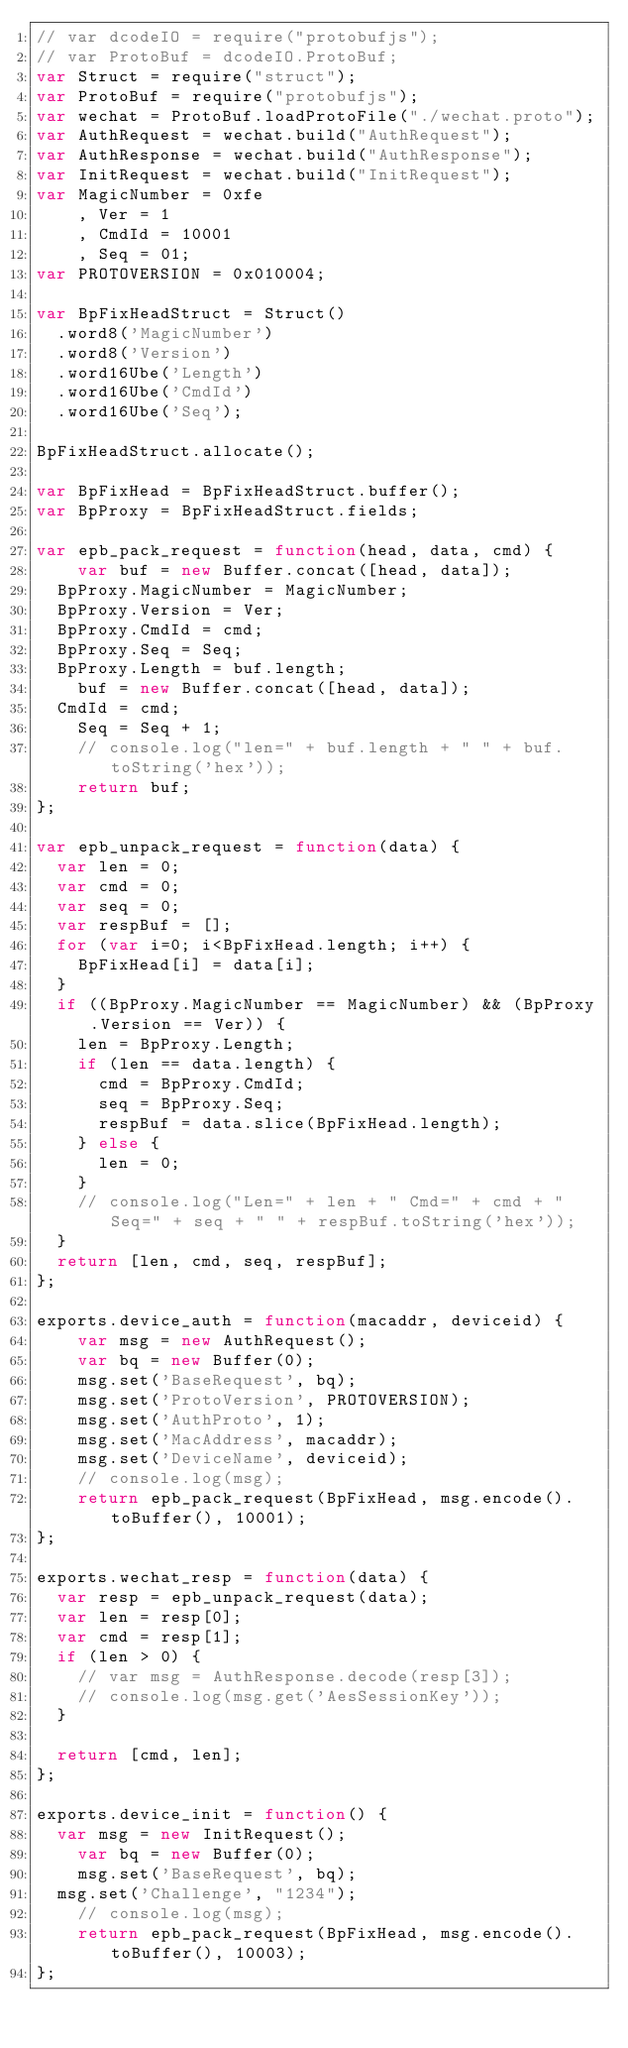<code> <loc_0><loc_0><loc_500><loc_500><_JavaScript_>// var dcodeIO = require("protobufjs");
// var ProtoBuf = dcodeIO.ProtoBuf;
var Struct = require("struct");
var ProtoBuf = require("protobufjs");
var wechat = ProtoBuf.loadProtoFile("./wechat.proto");
var AuthRequest = wechat.build("AuthRequest");
var AuthResponse = wechat.build("AuthResponse");
var InitRequest = wechat.build("InitRequest"); 
var MagicNumber = 0xfe
    , Ver = 1
    , CmdId = 10001
    , Seq = 01;
var PROTOVERSION = 0x010004;

var BpFixHeadStruct = Struct()
	.word8('MagicNumber')
	.word8('Version')
	.word16Ube('Length')
	.word16Ube('CmdId')
	.word16Ube('Seq');

BpFixHeadStruct.allocate();

var BpFixHead = BpFixHeadStruct.buffer();
var BpProxy = BpFixHeadStruct.fields;

var epb_pack_request = function(head, data, cmd) {
    var buf = new Buffer.concat([head, data]);
	BpProxy.MagicNumber = MagicNumber;
	BpProxy.Version = Ver;
	BpProxy.CmdId = cmd;
	BpProxy.Seq = Seq;
	BpProxy.Length = buf.length;
    buf = new Buffer.concat([head, data]);
	CmdId = cmd;
    Seq = Seq + 1;
    // console.log("len=" + buf.length + " " + buf.toString('hex'));
    return buf;
};

var epb_unpack_request = function(data) {
	var len = 0;
	var cmd = 0;
	var seq = 0;
	var respBuf = [];
	for (var i=0; i<BpFixHead.length; i++) {
		BpFixHead[i] = data[i];
	}
	if ((BpProxy.MagicNumber == MagicNumber) && (BpProxy.Version == Ver)) {
		len = BpProxy.Length;
		if (len == data.length) {
			cmd = BpProxy.CmdId;
			seq = BpProxy.Seq;
			respBuf = data.slice(BpFixHead.length);
		} else {
			len = 0;
		}
		// console.log("Len=" + len + " Cmd=" + cmd + " Seq=" + seq + " " + respBuf.toString('hex'));
	}
	return [len, cmd, seq, respBuf];
};

exports.device_auth = function(macaddr, deviceid) {
    var msg = new AuthRequest();
    var bq = new Buffer(0);
    msg.set('BaseRequest', bq);
    msg.set('ProtoVersion', PROTOVERSION);
    msg.set('AuthProto', 1);
    msg.set('MacAddress', macaddr);
    msg.set('DeviceName', deviceid);
    // console.log(msg);
    return epb_pack_request(BpFixHead, msg.encode().toBuffer(), 10001);
};

exports.wechat_resp = function(data) {
	var resp = epb_unpack_request(data);
	var len = resp[0];
	var cmd = resp[1];
	if (len > 0) {
		// var msg = AuthResponse.decode(resp[3]);
		// console.log(msg.get('AesSessionKey'));
	}

	return [cmd, len];
};

exports.device_init = function() {
	var msg = new InitRequest();
    var bq = new Buffer(0);
    msg.set('BaseRequest', bq);
	msg.set('Challenge', "1234");
    // console.log(msg);
    return epb_pack_request(BpFixHead, msg.encode().toBuffer(), 10003);
};
</code> 